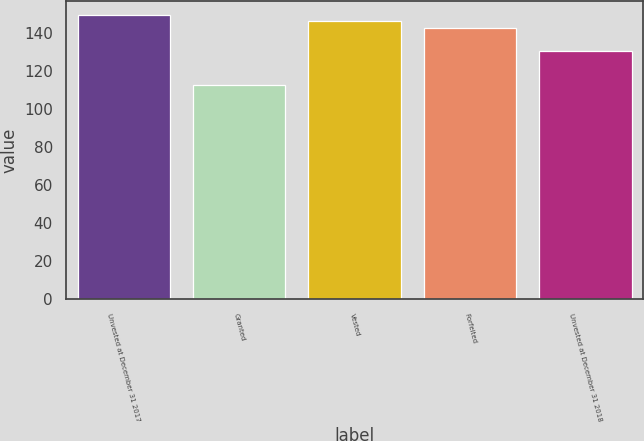<chart> <loc_0><loc_0><loc_500><loc_500><bar_chart><fcel>Unvested at December 31 2017<fcel>Granted<fcel>Vested<fcel>Forfeited<fcel>Unvested at December 31 2018<nl><fcel>149.46<fcel>112.88<fcel>146.22<fcel>142.98<fcel>130.46<nl></chart> 